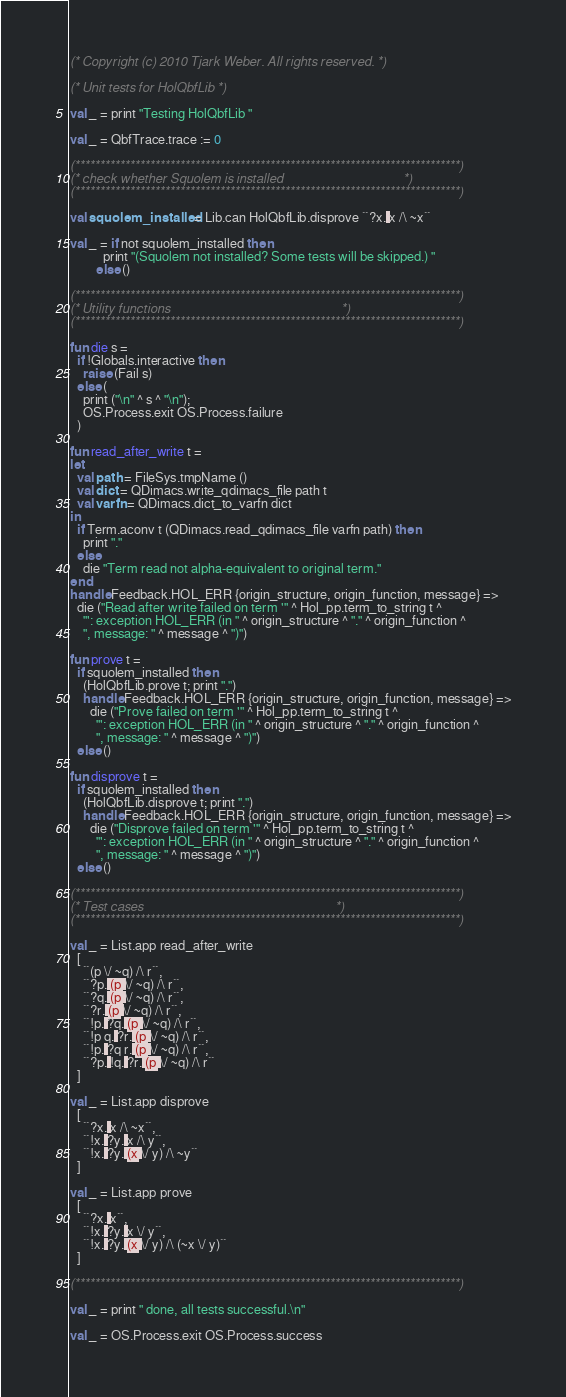Convert code to text. <code><loc_0><loc_0><loc_500><loc_500><_SML_>(* Copyright (c) 2010 Tjark Weber. All rights reserved. *)

(* Unit tests for HolQbfLib *)

val _ = print "Testing HolQbfLib "

val _ = QbfTrace.trace := 0

(*****************************************************************************)
(* check whether Squolem is installed                                        *)
(*****************************************************************************)

val squolem_installed = Lib.can HolQbfLib.disprove ``?x. x /\ ~x``

val _ = if not squolem_installed then
          print "(Squolem not installed? Some tests will be skipped.) "
        else ()

(*****************************************************************************)
(* Utility functions                                                         *)
(*****************************************************************************)

fun die s =
  if !Globals.interactive then
    raise (Fail s)
  else (
    print ("\n" ^ s ^ "\n");
    OS.Process.exit OS.Process.failure
  )

fun read_after_write t =
let
  val path = FileSys.tmpName ()
  val dict = QDimacs.write_qdimacs_file path t
  val varfn = QDimacs.dict_to_varfn dict
in
  if Term.aconv t (QDimacs.read_qdimacs_file varfn path) then
    print "."
  else
    die "Term read not alpha-equivalent to original term."
end
handle Feedback.HOL_ERR {origin_structure, origin_function, message} =>
  die ("Read after write failed on term '" ^ Hol_pp.term_to_string t ^
    "': exception HOL_ERR (in " ^ origin_structure ^ "." ^ origin_function ^
    ", message: " ^ message ^ ")")

fun prove t =
  if squolem_installed then
    (HolQbfLib.prove t; print ".")
    handle Feedback.HOL_ERR {origin_structure, origin_function, message} =>
      die ("Prove failed on term '" ^ Hol_pp.term_to_string t ^
        "': exception HOL_ERR (in " ^ origin_structure ^ "." ^ origin_function ^
        ", message: " ^ message ^ ")")
  else ()

fun disprove t =
  if squolem_installed then
    (HolQbfLib.disprove t; print ".")
    handle Feedback.HOL_ERR {origin_structure, origin_function, message} =>
      die ("Disprove failed on term '" ^ Hol_pp.term_to_string t ^
        "': exception HOL_ERR (in " ^ origin_structure ^ "." ^ origin_function ^
        ", message: " ^ message ^ ")")
  else ()

(*****************************************************************************)
(* Test cases                                                                *)
(*****************************************************************************)

val _ = List.app read_after_write
  [
    ``(p \/ ~q) /\ r``,
    ``?p. (p \/ ~q) /\ r``,
    ``?q. (p \/ ~q) /\ r``,
    ``?r. (p \/ ~q) /\ r``,
    ``!p. ?q. (p \/ ~q) /\ r``,
    ``!p q. ?r. (p \/ ~q) /\ r``,
    ``!p. ?q r. (p \/ ~q) /\ r``,
    ``?p. !q. ?r. (p \/ ~q) /\ r``
  ]

val _ = List.app disprove
  [
    ``?x. x /\ ~x``,
    ``!x. ?y. x /\ y``,
    ``!x. ?y. (x \/ y) /\ ~y``
  ]

val _ = List.app prove
  [
    ``?x. x``,
    ``!x. ?y. x \/ y``,
    ``!x. ?y. (x \/ y) /\ (~x \/ y)``
  ]

(*****************************************************************************)

val _ = print " done, all tests successful.\n"

val _ = OS.Process.exit OS.Process.success
</code> 